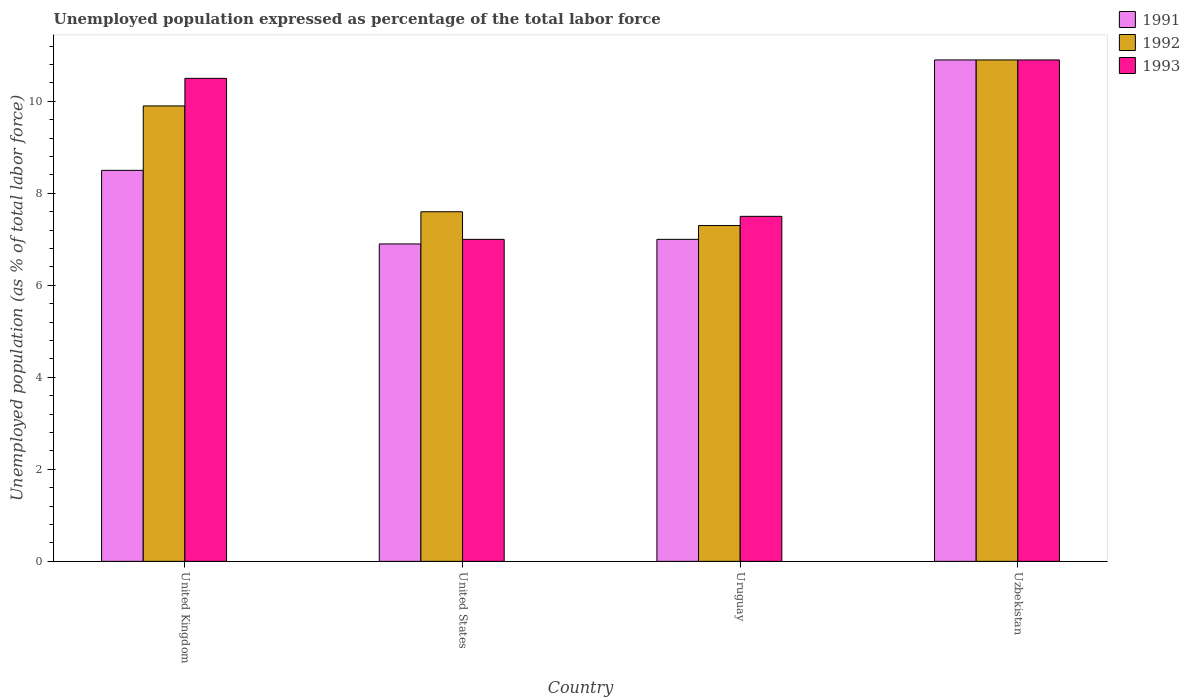How many different coloured bars are there?
Ensure brevity in your answer.  3. How many groups of bars are there?
Provide a succinct answer. 4. How many bars are there on the 4th tick from the right?
Make the answer very short. 3. What is the label of the 2nd group of bars from the left?
Your answer should be compact. United States. In how many cases, is the number of bars for a given country not equal to the number of legend labels?
Your answer should be compact. 0. What is the unemployment in in 1991 in United States?
Make the answer very short. 6.9. Across all countries, what is the maximum unemployment in in 1992?
Keep it short and to the point. 10.9. Across all countries, what is the minimum unemployment in in 1992?
Keep it short and to the point. 7.3. In which country was the unemployment in in 1991 maximum?
Make the answer very short. Uzbekistan. In which country was the unemployment in in 1991 minimum?
Ensure brevity in your answer.  United States. What is the total unemployment in in 1991 in the graph?
Your answer should be compact. 33.3. What is the difference between the unemployment in in 1992 in United Kingdom and that in Uruguay?
Make the answer very short. 2.6. What is the difference between the unemployment in in 1993 in Uruguay and the unemployment in in 1991 in Uzbekistan?
Give a very brief answer. -3.4. What is the average unemployment in in 1991 per country?
Offer a terse response. 8.32. What is the difference between the unemployment in of/in 1992 and unemployment in of/in 1993 in United Kingdom?
Your answer should be compact. -0.6. In how many countries, is the unemployment in in 1991 greater than 3.2 %?
Provide a short and direct response. 4. What is the ratio of the unemployment in in 1991 in United Kingdom to that in Uzbekistan?
Offer a very short reply. 0.78. What is the difference between the highest and the second highest unemployment in in 1992?
Keep it short and to the point. -1. What is the difference between the highest and the lowest unemployment in in 1993?
Ensure brevity in your answer.  3.9. In how many countries, is the unemployment in in 1991 greater than the average unemployment in in 1991 taken over all countries?
Your answer should be very brief. 2. What does the 2nd bar from the right in United Kingdom represents?
Your answer should be compact. 1992. Are all the bars in the graph horizontal?
Provide a succinct answer. No. What is the difference between two consecutive major ticks on the Y-axis?
Your response must be concise. 2. Does the graph contain any zero values?
Give a very brief answer. No. How many legend labels are there?
Offer a terse response. 3. What is the title of the graph?
Your response must be concise. Unemployed population expressed as percentage of the total labor force. Does "1992" appear as one of the legend labels in the graph?
Offer a terse response. Yes. What is the label or title of the X-axis?
Ensure brevity in your answer.  Country. What is the label or title of the Y-axis?
Provide a succinct answer. Unemployed population (as % of total labor force). What is the Unemployed population (as % of total labor force) in 1992 in United Kingdom?
Offer a very short reply. 9.9. What is the Unemployed population (as % of total labor force) in 1993 in United Kingdom?
Your answer should be compact. 10.5. What is the Unemployed population (as % of total labor force) of 1991 in United States?
Your answer should be compact. 6.9. What is the Unemployed population (as % of total labor force) in 1992 in United States?
Your answer should be very brief. 7.6. What is the Unemployed population (as % of total labor force) in 1991 in Uruguay?
Keep it short and to the point. 7. What is the Unemployed population (as % of total labor force) in 1992 in Uruguay?
Provide a short and direct response. 7.3. What is the Unemployed population (as % of total labor force) in 1991 in Uzbekistan?
Keep it short and to the point. 10.9. What is the Unemployed population (as % of total labor force) of 1992 in Uzbekistan?
Offer a very short reply. 10.9. What is the Unemployed population (as % of total labor force) of 1993 in Uzbekistan?
Make the answer very short. 10.9. Across all countries, what is the maximum Unemployed population (as % of total labor force) of 1991?
Ensure brevity in your answer.  10.9. Across all countries, what is the maximum Unemployed population (as % of total labor force) in 1992?
Make the answer very short. 10.9. Across all countries, what is the maximum Unemployed population (as % of total labor force) in 1993?
Keep it short and to the point. 10.9. Across all countries, what is the minimum Unemployed population (as % of total labor force) of 1991?
Your answer should be very brief. 6.9. Across all countries, what is the minimum Unemployed population (as % of total labor force) in 1992?
Make the answer very short. 7.3. Across all countries, what is the minimum Unemployed population (as % of total labor force) in 1993?
Your answer should be compact. 7. What is the total Unemployed population (as % of total labor force) of 1991 in the graph?
Your answer should be compact. 33.3. What is the total Unemployed population (as % of total labor force) of 1992 in the graph?
Your response must be concise. 35.7. What is the total Unemployed population (as % of total labor force) of 1993 in the graph?
Your response must be concise. 35.9. What is the difference between the Unemployed population (as % of total labor force) of 1992 in United Kingdom and that in United States?
Ensure brevity in your answer.  2.3. What is the difference between the Unemployed population (as % of total labor force) of 1993 in United Kingdom and that in United States?
Provide a short and direct response. 3.5. What is the difference between the Unemployed population (as % of total labor force) in 1993 in United Kingdom and that in Uruguay?
Keep it short and to the point. 3. What is the difference between the Unemployed population (as % of total labor force) of 1991 in United States and that in Uruguay?
Your answer should be compact. -0.1. What is the difference between the Unemployed population (as % of total labor force) of 1992 in United States and that in Uruguay?
Keep it short and to the point. 0.3. What is the difference between the Unemployed population (as % of total labor force) in 1992 in United States and that in Uzbekistan?
Ensure brevity in your answer.  -3.3. What is the difference between the Unemployed population (as % of total labor force) of 1993 in United States and that in Uzbekistan?
Make the answer very short. -3.9. What is the difference between the Unemployed population (as % of total labor force) of 1991 in Uruguay and that in Uzbekistan?
Provide a short and direct response. -3.9. What is the difference between the Unemployed population (as % of total labor force) in 1991 in United Kingdom and the Unemployed population (as % of total labor force) in 1992 in United States?
Provide a succinct answer. 0.9. What is the difference between the Unemployed population (as % of total labor force) in 1992 in United Kingdom and the Unemployed population (as % of total labor force) in 1993 in United States?
Offer a very short reply. 2.9. What is the difference between the Unemployed population (as % of total labor force) of 1991 in United Kingdom and the Unemployed population (as % of total labor force) of 1992 in Uzbekistan?
Give a very brief answer. -2.4. What is the difference between the Unemployed population (as % of total labor force) of 1991 in United Kingdom and the Unemployed population (as % of total labor force) of 1993 in Uzbekistan?
Your response must be concise. -2.4. What is the difference between the Unemployed population (as % of total labor force) of 1991 in United States and the Unemployed population (as % of total labor force) of 1992 in Uruguay?
Offer a very short reply. -0.4. What is the difference between the Unemployed population (as % of total labor force) of 1991 in United States and the Unemployed population (as % of total labor force) of 1993 in Uruguay?
Your answer should be compact. -0.6. What is the difference between the Unemployed population (as % of total labor force) in 1992 in United States and the Unemployed population (as % of total labor force) in 1993 in Uzbekistan?
Your response must be concise. -3.3. What is the difference between the Unemployed population (as % of total labor force) in 1991 in Uruguay and the Unemployed population (as % of total labor force) in 1993 in Uzbekistan?
Offer a terse response. -3.9. What is the difference between the Unemployed population (as % of total labor force) of 1992 in Uruguay and the Unemployed population (as % of total labor force) of 1993 in Uzbekistan?
Offer a very short reply. -3.6. What is the average Unemployed population (as % of total labor force) in 1991 per country?
Make the answer very short. 8.32. What is the average Unemployed population (as % of total labor force) in 1992 per country?
Keep it short and to the point. 8.93. What is the average Unemployed population (as % of total labor force) of 1993 per country?
Ensure brevity in your answer.  8.97. What is the difference between the Unemployed population (as % of total labor force) of 1991 and Unemployed population (as % of total labor force) of 1992 in United Kingdom?
Make the answer very short. -1.4. What is the difference between the Unemployed population (as % of total labor force) in 1992 and Unemployed population (as % of total labor force) in 1993 in United Kingdom?
Give a very brief answer. -0.6. What is the difference between the Unemployed population (as % of total labor force) of 1991 and Unemployed population (as % of total labor force) of 1992 in United States?
Offer a very short reply. -0.7. What is the difference between the Unemployed population (as % of total labor force) in 1992 and Unemployed population (as % of total labor force) in 1993 in United States?
Make the answer very short. 0.6. What is the difference between the Unemployed population (as % of total labor force) in 1991 and Unemployed population (as % of total labor force) in 1992 in Uruguay?
Keep it short and to the point. -0.3. What is the difference between the Unemployed population (as % of total labor force) of 1992 and Unemployed population (as % of total labor force) of 1993 in Uruguay?
Make the answer very short. -0.2. What is the difference between the Unemployed population (as % of total labor force) in 1991 and Unemployed population (as % of total labor force) in 1992 in Uzbekistan?
Your answer should be compact. 0. What is the difference between the Unemployed population (as % of total labor force) of 1991 and Unemployed population (as % of total labor force) of 1993 in Uzbekistan?
Keep it short and to the point. 0. What is the ratio of the Unemployed population (as % of total labor force) in 1991 in United Kingdom to that in United States?
Keep it short and to the point. 1.23. What is the ratio of the Unemployed population (as % of total labor force) in 1992 in United Kingdom to that in United States?
Your answer should be compact. 1.3. What is the ratio of the Unemployed population (as % of total labor force) in 1991 in United Kingdom to that in Uruguay?
Keep it short and to the point. 1.21. What is the ratio of the Unemployed population (as % of total labor force) in 1992 in United Kingdom to that in Uruguay?
Give a very brief answer. 1.36. What is the ratio of the Unemployed population (as % of total labor force) of 1991 in United Kingdom to that in Uzbekistan?
Provide a short and direct response. 0.78. What is the ratio of the Unemployed population (as % of total labor force) in 1992 in United Kingdom to that in Uzbekistan?
Give a very brief answer. 0.91. What is the ratio of the Unemployed population (as % of total labor force) of 1993 in United Kingdom to that in Uzbekistan?
Your answer should be very brief. 0.96. What is the ratio of the Unemployed population (as % of total labor force) of 1991 in United States to that in Uruguay?
Provide a succinct answer. 0.99. What is the ratio of the Unemployed population (as % of total labor force) of 1992 in United States to that in Uruguay?
Provide a short and direct response. 1.04. What is the ratio of the Unemployed population (as % of total labor force) of 1993 in United States to that in Uruguay?
Provide a succinct answer. 0.93. What is the ratio of the Unemployed population (as % of total labor force) of 1991 in United States to that in Uzbekistan?
Offer a terse response. 0.63. What is the ratio of the Unemployed population (as % of total labor force) of 1992 in United States to that in Uzbekistan?
Provide a succinct answer. 0.7. What is the ratio of the Unemployed population (as % of total labor force) in 1993 in United States to that in Uzbekistan?
Offer a terse response. 0.64. What is the ratio of the Unemployed population (as % of total labor force) in 1991 in Uruguay to that in Uzbekistan?
Make the answer very short. 0.64. What is the ratio of the Unemployed population (as % of total labor force) of 1992 in Uruguay to that in Uzbekistan?
Make the answer very short. 0.67. What is the ratio of the Unemployed population (as % of total labor force) of 1993 in Uruguay to that in Uzbekistan?
Ensure brevity in your answer.  0.69. What is the difference between the highest and the second highest Unemployed population (as % of total labor force) of 1992?
Offer a very short reply. 1. What is the difference between the highest and the second highest Unemployed population (as % of total labor force) in 1993?
Your answer should be very brief. 0.4. What is the difference between the highest and the lowest Unemployed population (as % of total labor force) of 1992?
Your answer should be compact. 3.6. What is the difference between the highest and the lowest Unemployed population (as % of total labor force) of 1993?
Offer a very short reply. 3.9. 